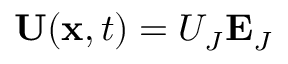Convert formula to latex. <formula><loc_0><loc_0><loc_500><loc_500>\ U ( x , t ) = U _ { J } E _ { J }</formula> 